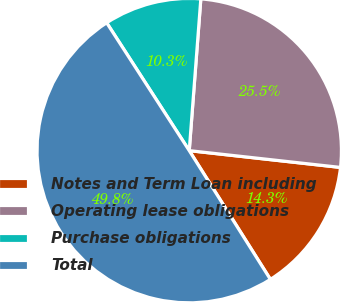<chart> <loc_0><loc_0><loc_500><loc_500><pie_chart><fcel>Notes and Term Loan including<fcel>Operating lease obligations<fcel>Purchase obligations<fcel>Total<nl><fcel>14.29%<fcel>25.55%<fcel>10.34%<fcel>49.83%<nl></chart> 